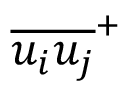Convert formula to latex. <formula><loc_0><loc_0><loc_500><loc_500>{ \overline { { { u _ { i } } { u _ { j } } } } } ^ { + }</formula> 